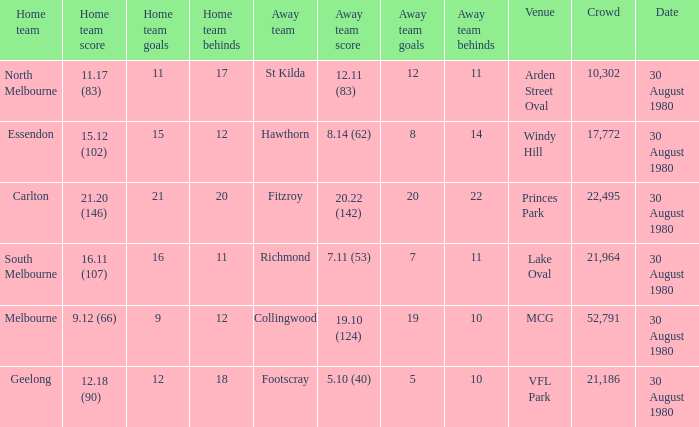What was the crowd when the away team is footscray? 21186.0. 